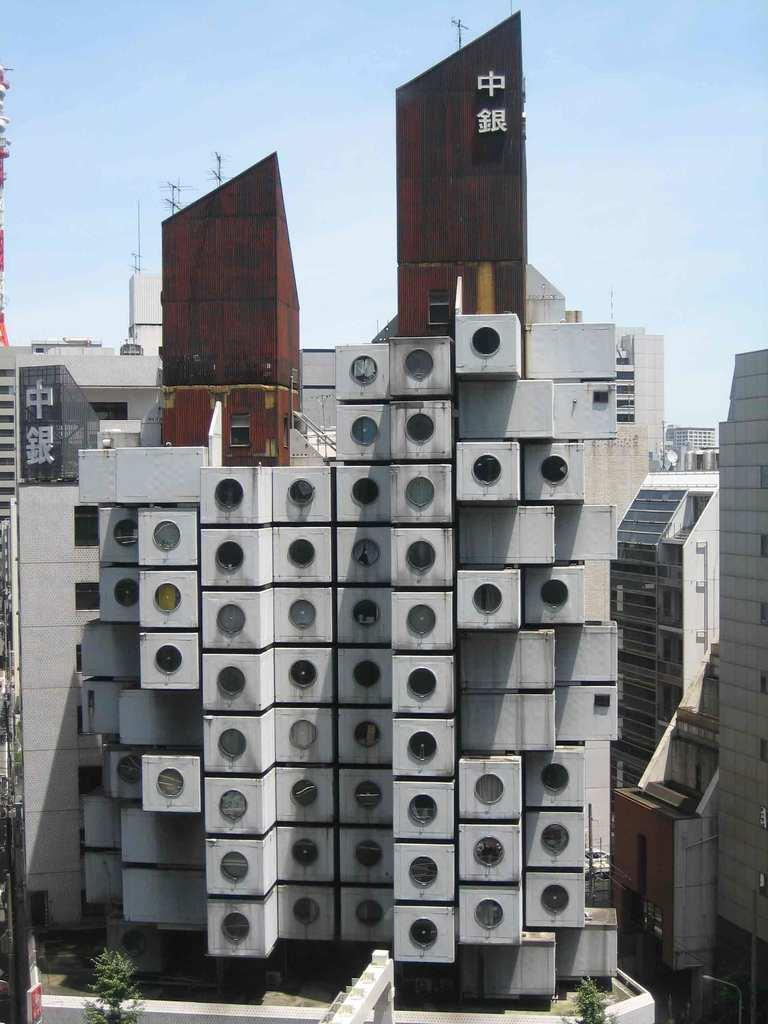<image>
Summarize the visual content of the image. An odd building has Asian writing at the top of it. 